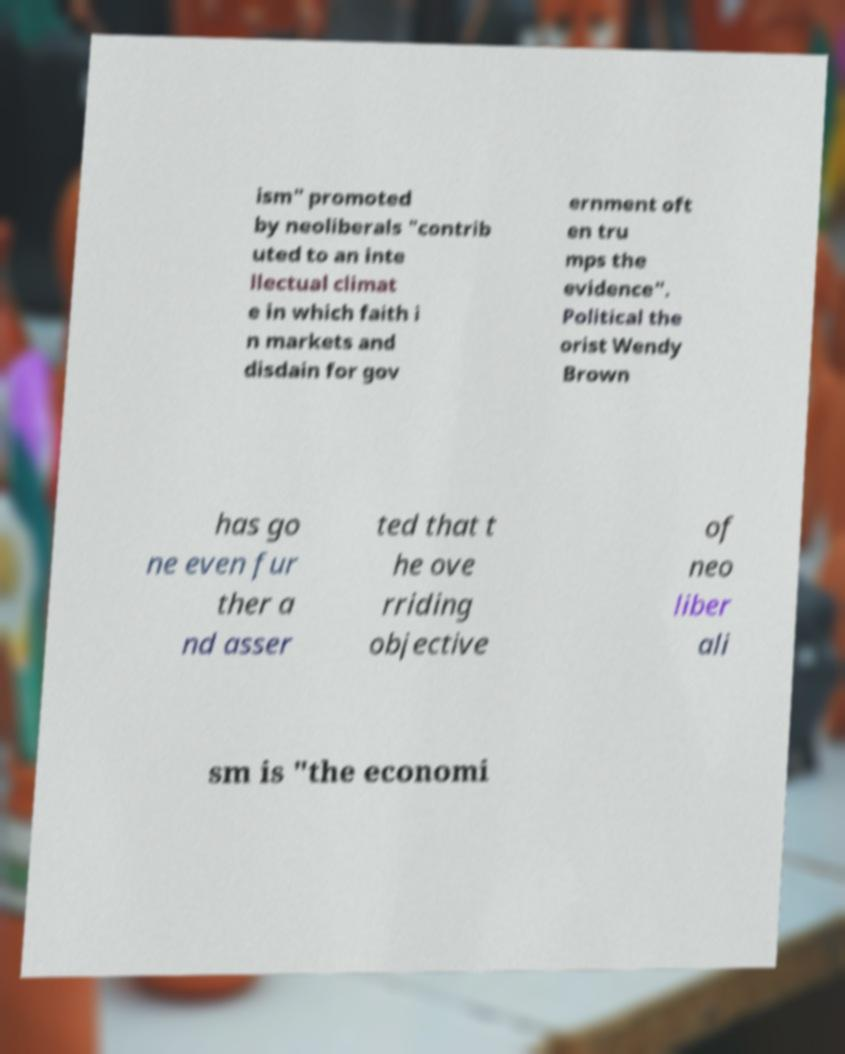Could you assist in decoding the text presented in this image and type it out clearly? ism" promoted by neoliberals "contrib uted to an inte llectual climat e in which faith i n markets and disdain for gov ernment oft en tru mps the evidence". Political the orist Wendy Brown has go ne even fur ther a nd asser ted that t he ove rriding objective of neo liber ali sm is "the economi 